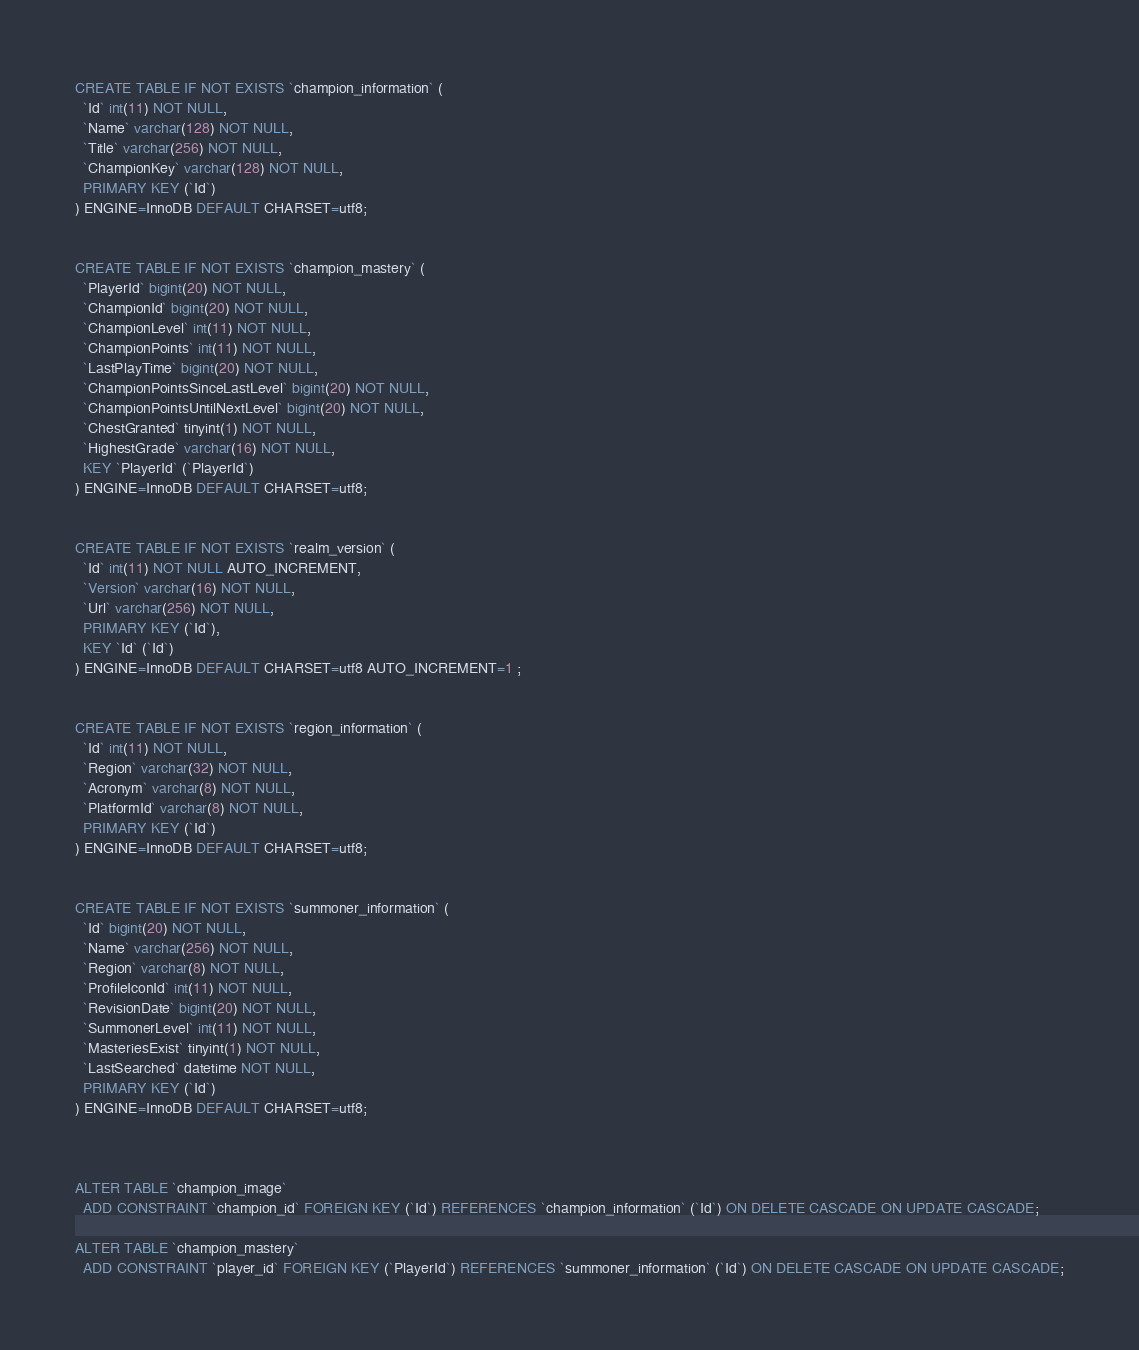<code> <loc_0><loc_0><loc_500><loc_500><_SQL_>CREATE TABLE IF NOT EXISTS `champion_information` (
  `Id` int(11) NOT NULL,
  `Name` varchar(128) NOT NULL,
  `Title` varchar(256) NOT NULL,
  `ChampionKey` varchar(128) NOT NULL,
  PRIMARY KEY (`Id`)
) ENGINE=InnoDB DEFAULT CHARSET=utf8;


CREATE TABLE IF NOT EXISTS `champion_mastery` (
  `PlayerId` bigint(20) NOT NULL,
  `ChampionId` bigint(20) NOT NULL,
  `ChampionLevel` int(11) NOT NULL,
  `ChampionPoints` int(11) NOT NULL,
  `LastPlayTime` bigint(20) NOT NULL,
  `ChampionPointsSinceLastLevel` bigint(20) NOT NULL,
  `ChampionPointsUntilNextLevel` bigint(20) NOT NULL,
  `ChestGranted` tinyint(1) NOT NULL,
  `HighestGrade` varchar(16) NOT NULL,
  KEY `PlayerId` (`PlayerId`)
) ENGINE=InnoDB DEFAULT CHARSET=utf8;


CREATE TABLE IF NOT EXISTS `realm_version` (
  `Id` int(11) NOT NULL AUTO_INCREMENT,
  `Version` varchar(16) NOT NULL,
  `Url` varchar(256) NOT NULL,
  PRIMARY KEY (`Id`),
  KEY `Id` (`Id`)
) ENGINE=InnoDB DEFAULT CHARSET=utf8 AUTO_INCREMENT=1 ;


CREATE TABLE IF NOT EXISTS `region_information` (
  `Id` int(11) NOT NULL,
  `Region` varchar(32) NOT NULL,
  `Acronym` varchar(8) NOT NULL,
  `PlatformId` varchar(8) NOT NULL,
  PRIMARY KEY (`Id`)
) ENGINE=InnoDB DEFAULT CHARSET=utf8;


CREATE TABLE IF NOT EXISTS `summoner_information` (
  `Id` bigint(20) NOT NULL,
  `Name` varchar(256) NOT NULL,
  `Region` varchar(8) NOT NULL,
  `ProfileIconId` int(11) NOT NULL,
  `RevisionDate` bigint(20) NOT NULL,
  `SummonerLevel` int(11) NOT NULL,
  `MasteriesExist` tinyint(1) NOT NULL,
  `LastSearched` datetime NOT NULL,
  PRIMARY KEY (`Id`)
) ENGINE=InnoDB DEFAULT CHARSET=utf8;



ALTER TABLE `champion_image`
  ADD CONSTRAINT `champion_id` FOREIGN KEY (`Id`) REFERENCES `champion_information` (`Id`) ON DELETE CASCADE ON UPDATE CASCADE;

ALTER TABLE `champion_mastery`
  ADD CONSTRAINT `player_id` FOREIGN KEY (`PlayerId`) REFERENCES `summoner_information` (`Id`) ON DELETE CASCADE ON UPDATE CASCADE;</code> 